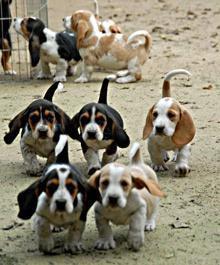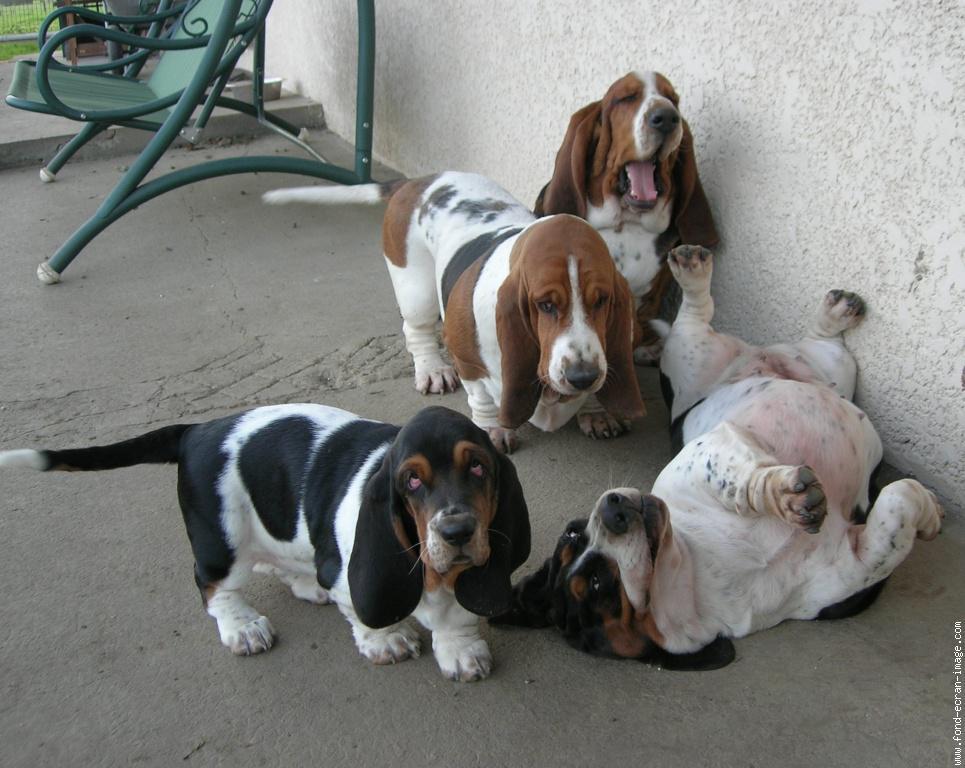The first image is the image on the left, the second image is the image on the right. Assess this claim about the two images: "There are at least two dogs walking in the same direction.". Correct or not? Answer yes or no. Yes. The first image is the image on the left, the second image is the image on the right. Considering the images on both sides, is "There are three dogs." valid? Answer yes or no. No. 